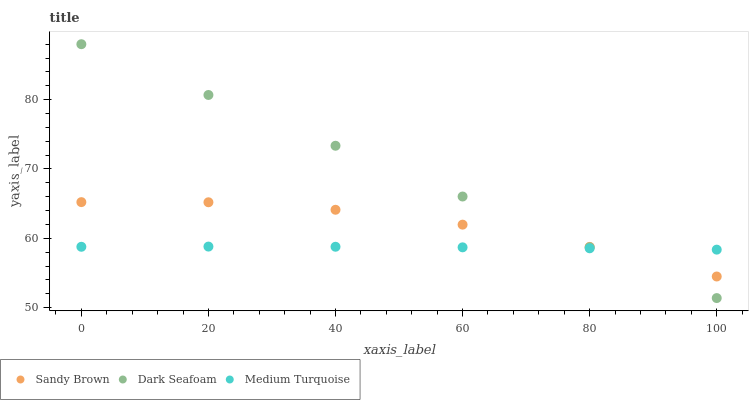Does Medium Turquoise have the minimum area under the curve?
Answer yes or no. Yes. Does Dark Seafoam have the maximum area under the curve?
Answer yes or no. Yes. Does Sandy Brown have the minimum area under the curve?
Answer yes or no. No. Does Sandy Brown have the maximum area under the curve?
Answer yes or no. No. Is Dark Seafoam the smoothest?
Answer yes or no. Yes. Is Sandy Brown the roughest?
Answer yes or no. Yes. Is Medium Turquoise the smoothest?
Answer yes or no. No. Is Medium Turquoise the roughest?
Answer yes or no. No. Does Dark Seafoam have the lowest value?
Answer yes or no. Yes. Does Sandy Brown have the lowest value?
Answer yes or no. No. Does Dark Seafoam have the highest value?
Answer yes or no. Yes. Does Sandy Brown have the highest value?
Answer yes or no. No. Does Medium Turquoise intersect Dark Seafoam?
Answer yes or no. Yes. Is Medium Turquoise less than Dark Seafoam?
Answer yes or no. No. Is Medium Turquoise greater than Dark Seafoam?
Answer yes or no. No. 